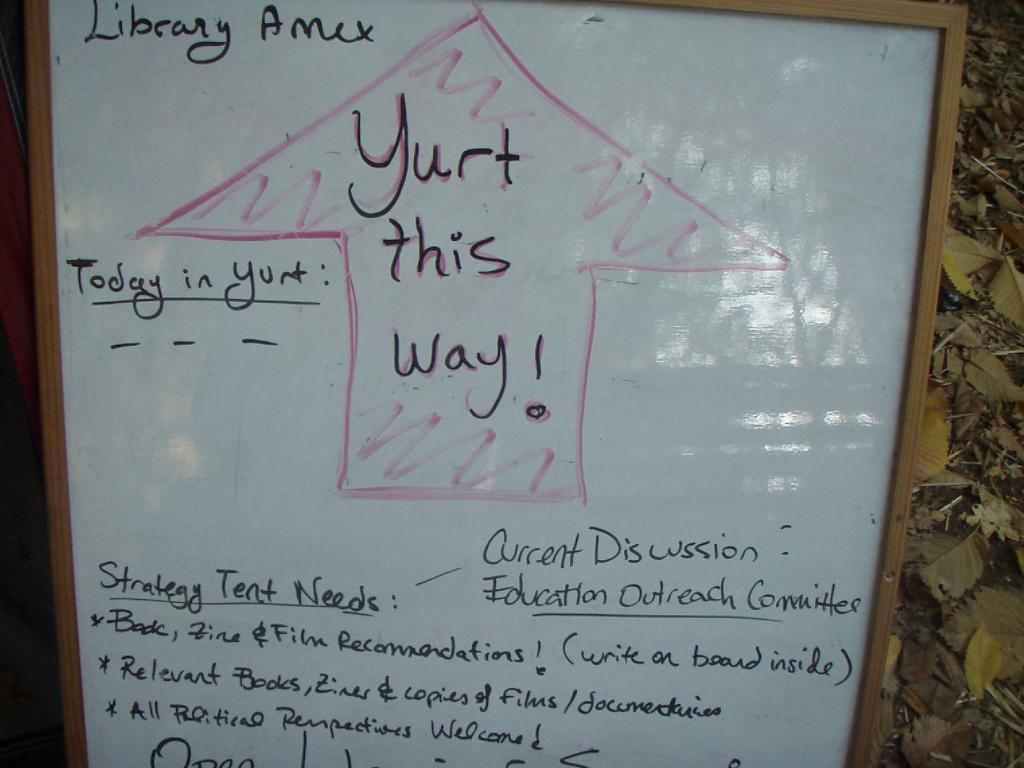<image>
Summarize the visual content of the image. A whiteboard with an arrow pointing to Yurt along with other messages. 